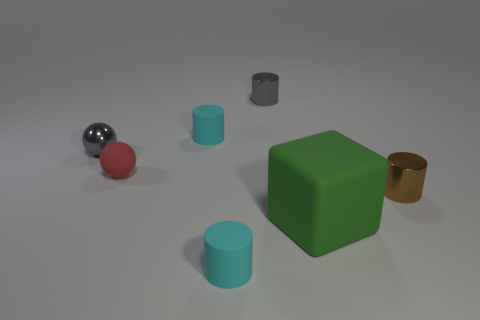Does the small matte sphere have the same color as the small metallic thing that is left of the tiny gray cylinder?
Ensure brevity in your answer.  No. What is the shape of the thing that is both in front of the red thing and left of the gray cylinder?
Offer a very short reply. Cylinder. How many small brown cylinders are there?
Provide a short and direct response. 1. There is a tiny metallic object that is the same color as the tiny metallic sphere; what shape is it?
Give a very brief answer. Cylinder. What is the size of the other metal thing that is the same shape as the small red object?
Your answer should be compact. Small. Does the metallic thing that is to the right of the green rubber cube have the same shape as the big object?
Give a very brief answer. No. What color is the small rubber object behind the gray metallic ball?
Make the answer very short. Cyan. How many other objects are there of the same size as the metal sphere?
Keep it short and to the point. 5. Are there any other things that have the same shape as the green thing?
Provide a succinct answer. No. Is the number of brown shiny cylinders behind the tiny brown thing the same as the number of red things?
Offer a very short reply. No. 